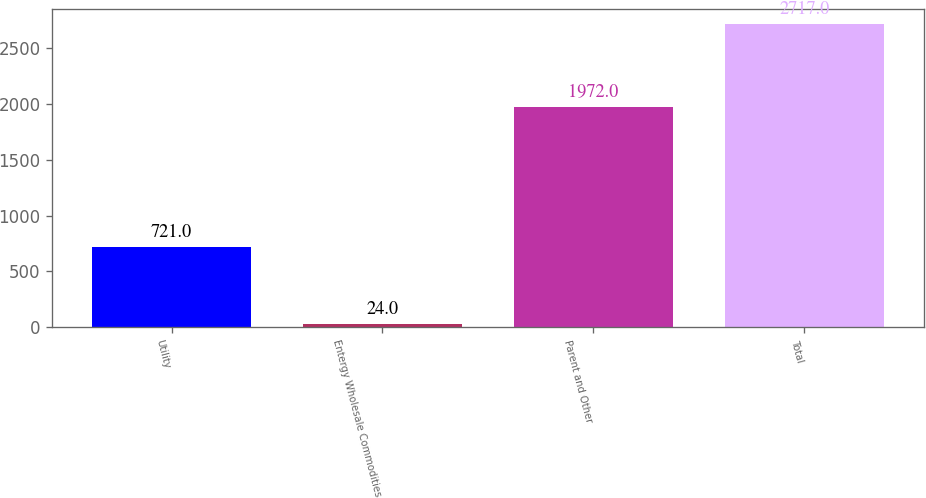Convert chart. <chart><loc_0><loc_0><loc_500><loc_500><bar_chart><fcel>Utility<fcel>Entergy Wholesale Commodities<fcel>Parent and Other<fcel>Total<nl><fcel>721<fcel>24<fcel>1972<fcel>2717<nl></chart> 